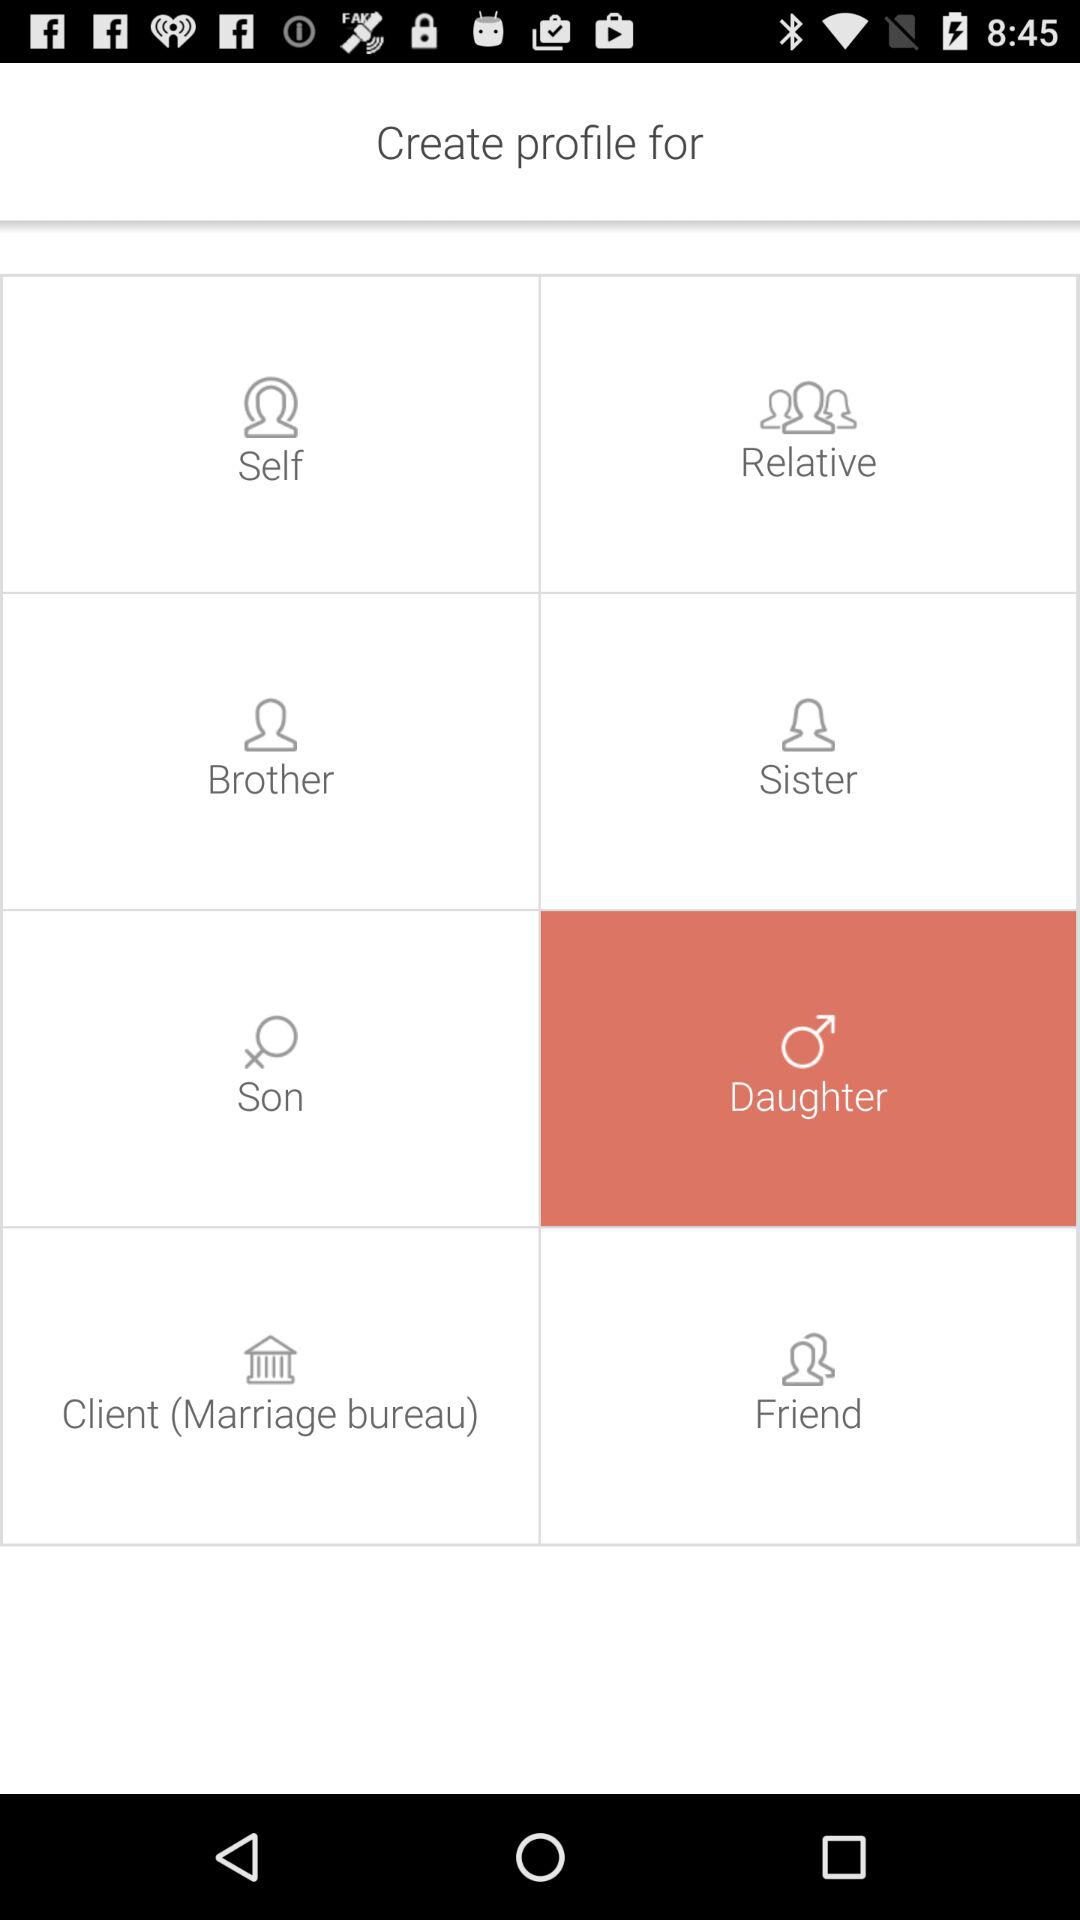How old is the daughter?
When the provided information is insufficient, respond with <no answer>. <no answer> 